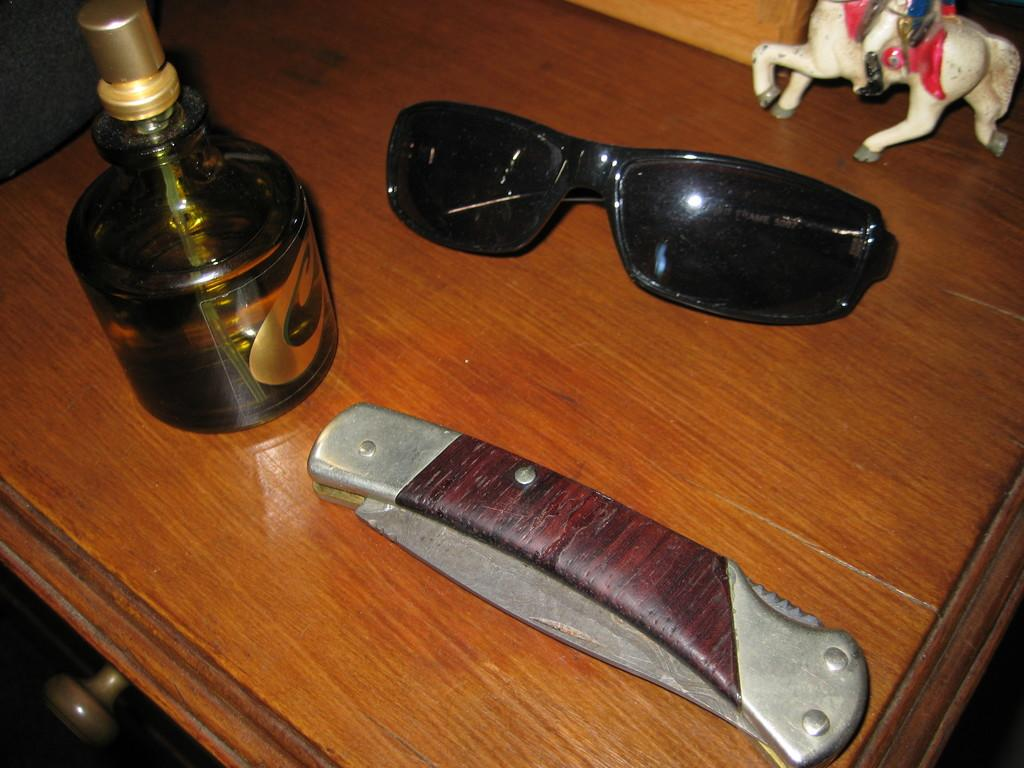What piece of furniture is present in the image? There is a table in the image. What items can be seen on the table? There are glasses, a knife, a perfume, and a figurine on the table. Can you describe the type of knife on the table? The facts do not specify the type of knife, but it is present on the table. What type of cake is being served by the fairies in the image? There are no fairies or cake present in the image. 